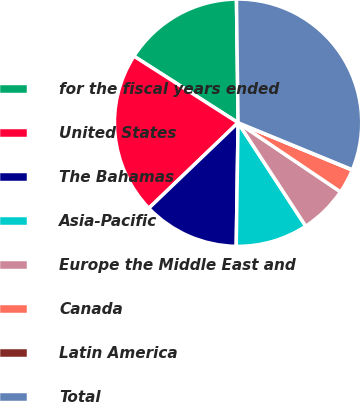Convert chart. <chart><loc_0><loc_0><loc_500><loc_500><pie_chart><fcel>for the fiscal years ended<fcel>United States<fcel>The Bahamas<fcel>Asia-Pacific<fcel>Europe the Middle East and<fcel>Canada<fcel>Latin America<fcel>Total<nl><fcel>15.74%<fcel>21.21%<fcel>12.6%<fcel>9.46%<fcel>6.33%<fcel>3.19%<fcel>0.05%<fcel>31.42%<nl></chart> 